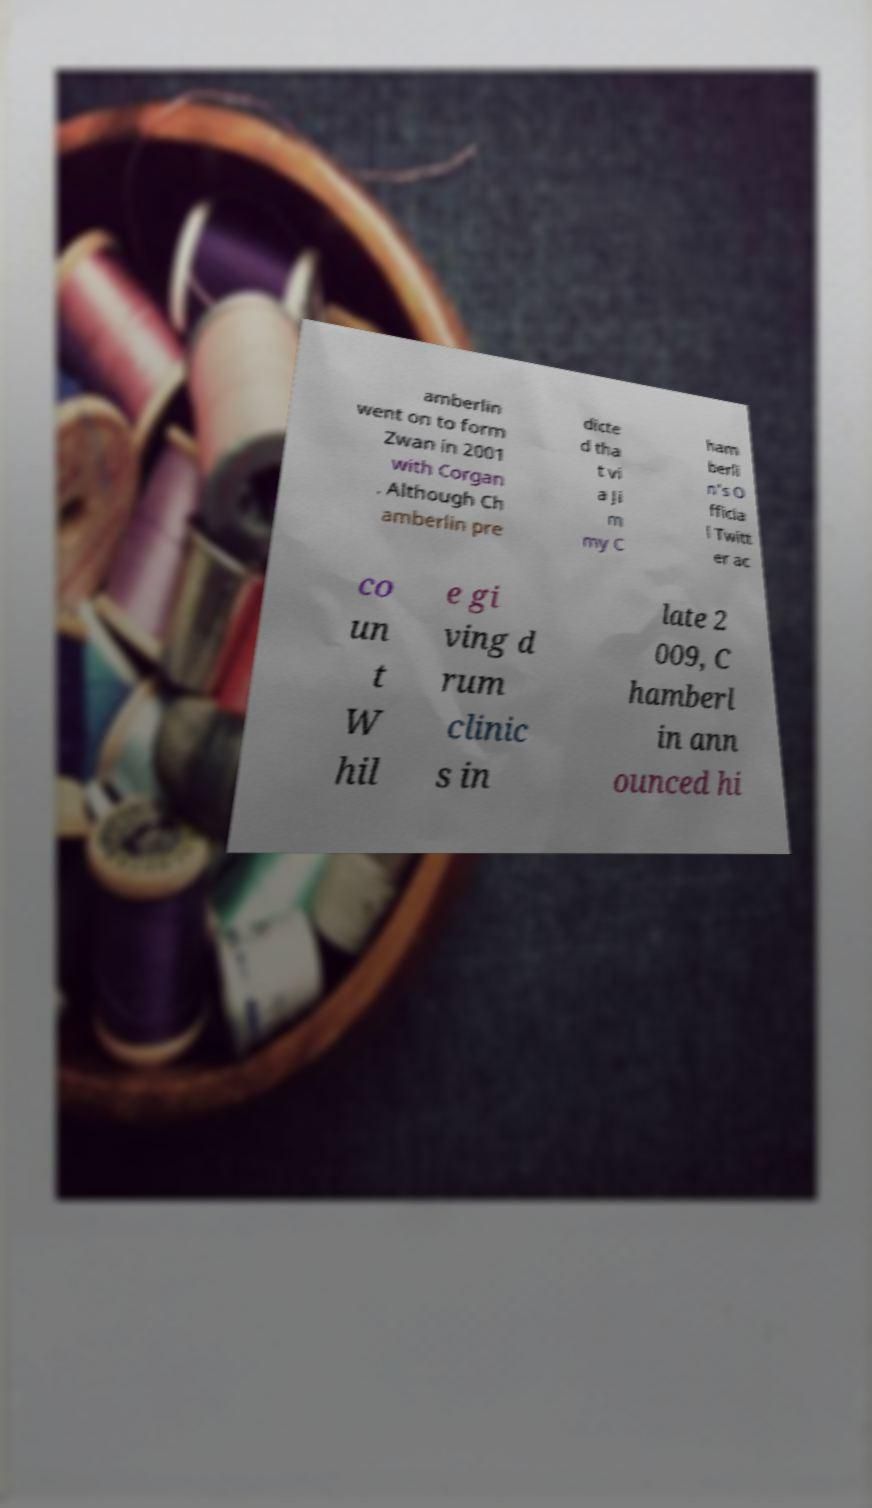Can you read and provide the text displayed in the image?This photo seems to have some interesting text. Can you extract and type it out for me? amberlin went on to form Zwan in 2001 with Corgan . Although Ch amberlin pre dicte d tha t vi a Ji m my C ham berli n's O fficia l Twitt er ac co un t W hil e gi ving d rum clinic s in late 2 009, C hamberl in ann ounced hi 